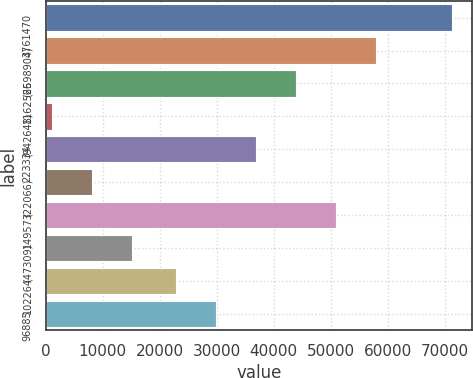Convert chart. <chart><loc_0><loc_0><loc_500><loc_500><bar_chart><fcel>3761470<fcel>(2598904)<fcel>1162566<fcel>(942648)<fcel>223334<fcel>(22066)<fcel>149573<fcel>(47309)<fcel>102264<fcel>96885<nl><fcel>71196<fcel>57851<fcel>43825<fcel>1066<fcel>36812<fcel>8079<fcel>50838<fcel>15092<fcel>22786<fcel>29799<nl></chart> 